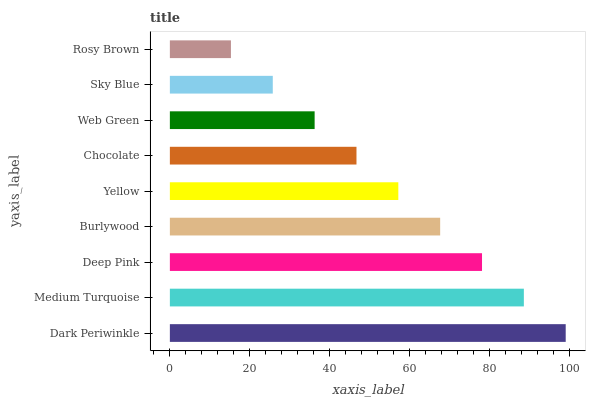Is Rosy Brown the minimum?
Answer yes or no. Yes. Is Dark Periwinkle the maximum?
Answer yes or no. Yes. Is Medium Turquoise the minimum?
Answer yes or no. No. Is Medium Turquoise the maximum?
Answer yes or no. No. Is Dark Periwinkle greater than Medium Turquoise?
Answer yes or no. Yes. Is Medium Turquoise less than Dark Periwinkle?
Answer yes or no. Yes. Is Medium Turquoise greater than Dark Periwinkle?
Answer yes or no. No. Is Dark Periwinkle less than Medium Turquoise?
Answer yes or no. No. Is Yellow the high median?
Answer yes or no. Yes. Is Yellow the low median?
Answer yes or no. Yes. Is Web Green the high median?
Answer yes or no. No. Is Burlywood the low median?
Answer yes or no. No. 